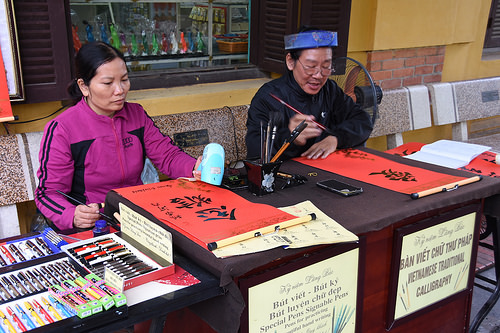<image>
Is the brush above the pen? Yes. The brush is positioned above the pen in the vertical space, higher up in the scene. 